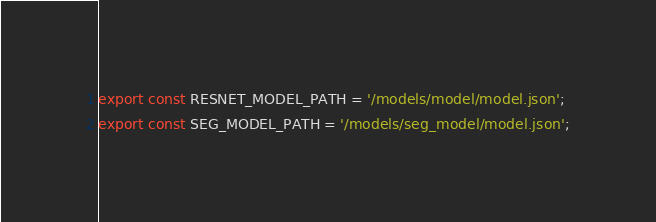<code> <loc_0><loc_0><loc_500><loc_500><_TypeScript_>export const RESNET_MODEL_PATH = '/models/model/model.json';
export const SEG_MODEL_PATH = '/models/seg_model/model.json';</code> 